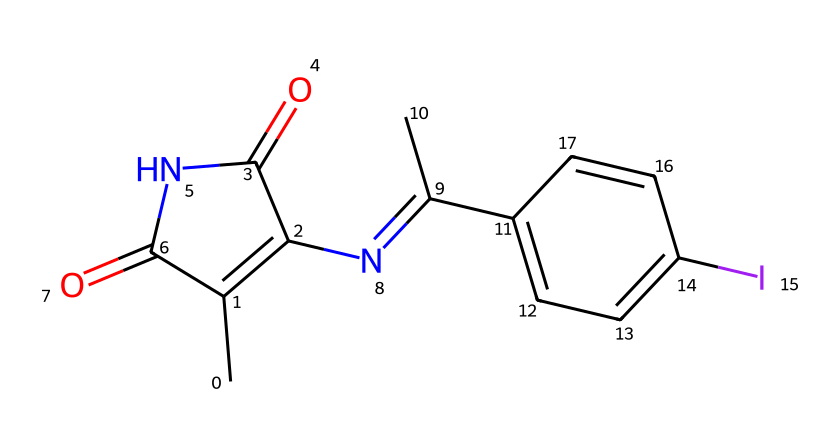What is the central atom in this compound? The central atom is iodine, as it is indicated by the 'I' in the structure. Iodine plays a vital role in thyroid medications.
Answer: iodine How many rings are present in this structure? The structure shows two distinct rings that can be identified by the cyclic arrangement of carbon atoms. The presence of double bonds and the connection points confirm the rings.
Answer: 2 What type of functional group is present in this compound? The presence of the -C=O (carbonyl) and -N= (imine) suggests that the functional groups are ketones and imines, which are significant in pharmaceutical chemistry.
Answer: ketone and imine How many nitrogen atoms are present in this chemical? By visual inspection of the SMILES representation, I can count two nitrogen atoms (N) that are part of the structure. These nitrogen atoms are often involved in various chemical reactions.
Answer: 2 What is the oxidation state of iodine in this compound? The oxidation state of iodine in hypervalent compounds like this one (due to bond connectivity and the presence of multiple bonds to carbon) can be determined to be +1, a common oxidation state for iodine.
Answer: +1 